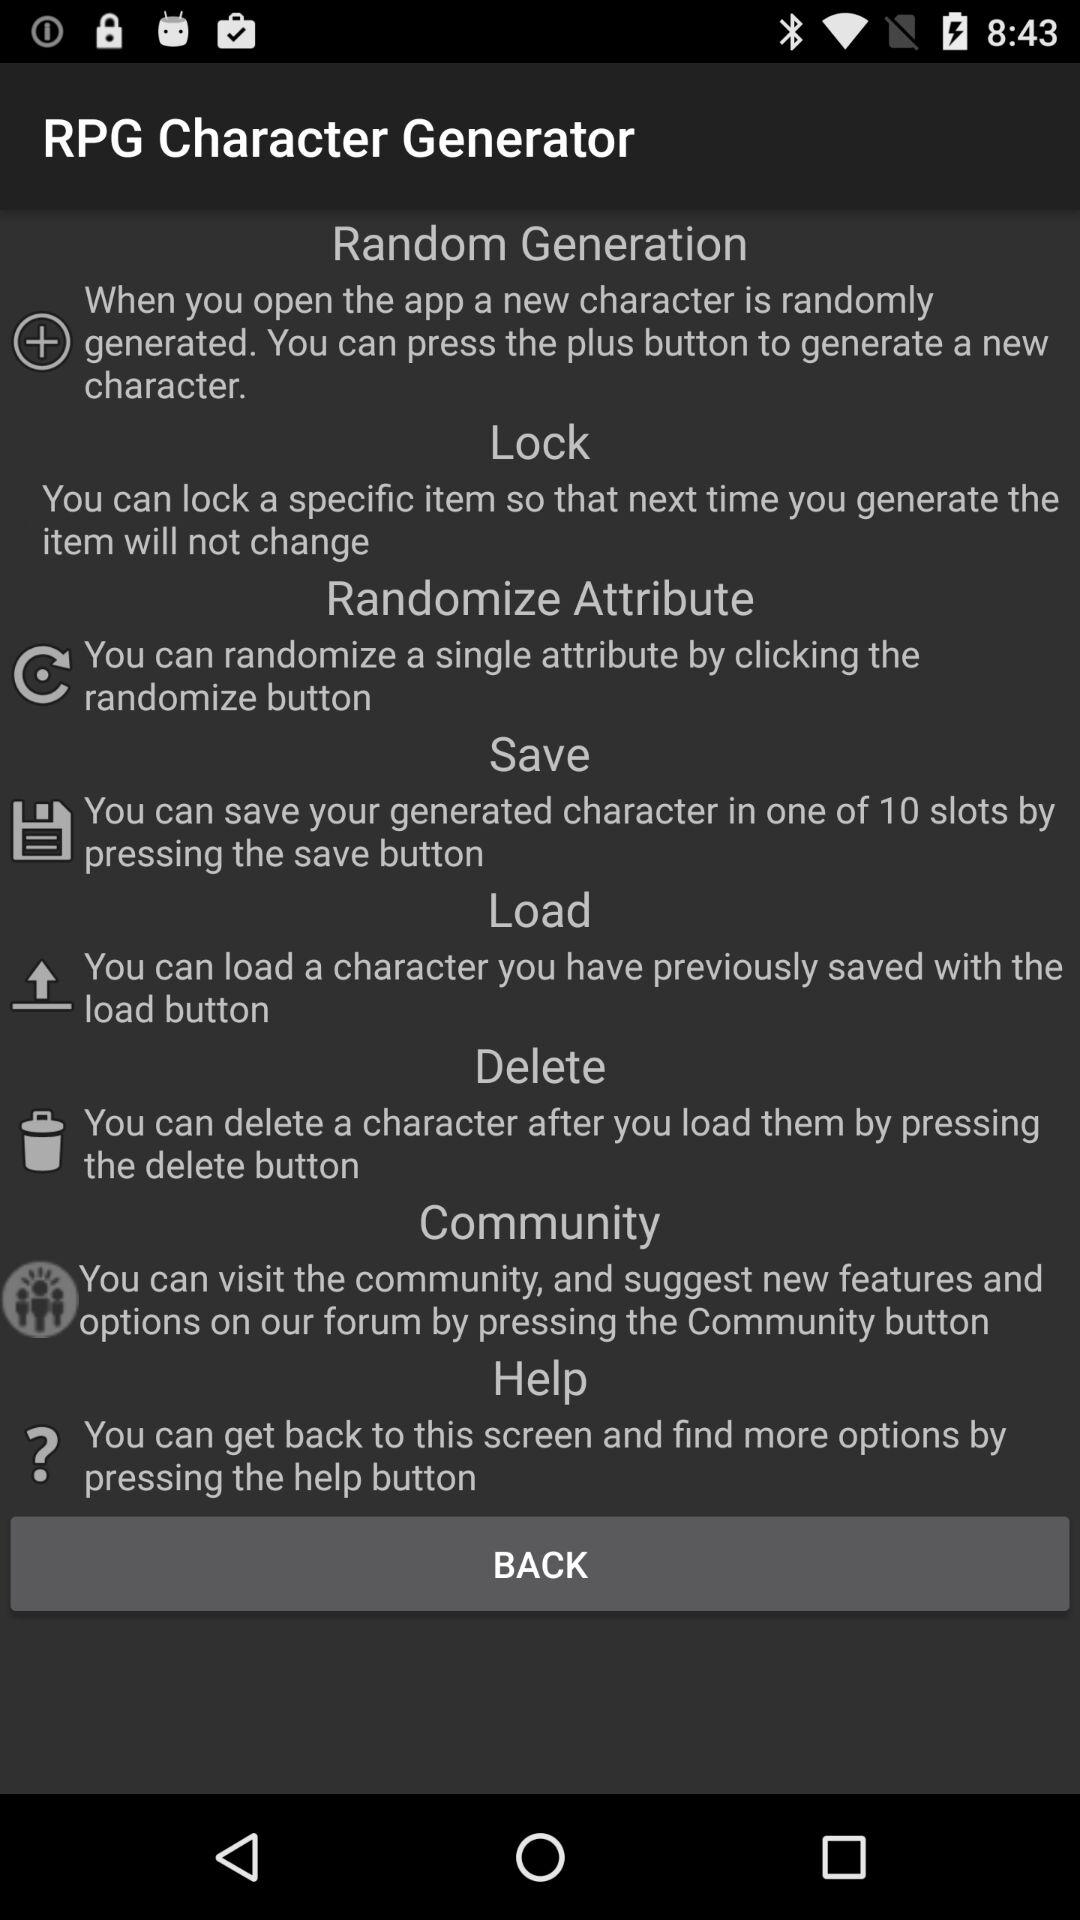How many items can be saved?
Answer the question using a single word or phrase. 10 